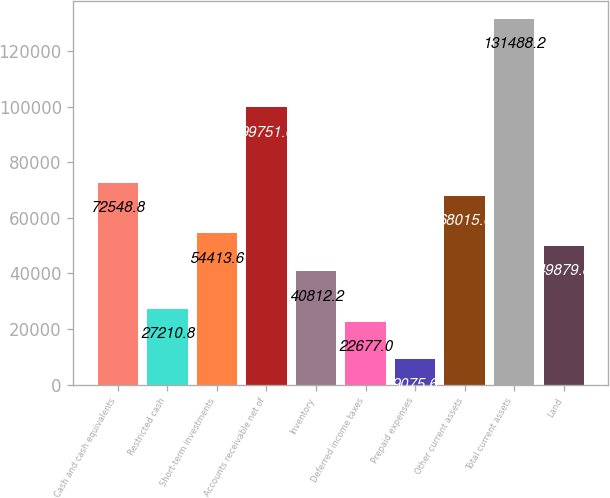Convert chart. <chart><loc_0><loc_0><loc_500><loc_500><bar_chart><fcel>Cash and cash equivalents<fcel>Restricted cash<fcel>Short-term investments<fcel>Accounts receivable net of<fcel>Inventory<fcel>Deferred income taxes<fcel>Prepaid expenses<fcel>Other current assets<fcel>Total current assets<fcel>Land<nl><fcel>72548.8<fcel>27210.8<fcel>54413.6<fcel>99751.6<fcel>40812.2<fcel>22677<fcel>9075.6<fcel>68015<fcel>131488<fcel>49879.8<nl></chart> 